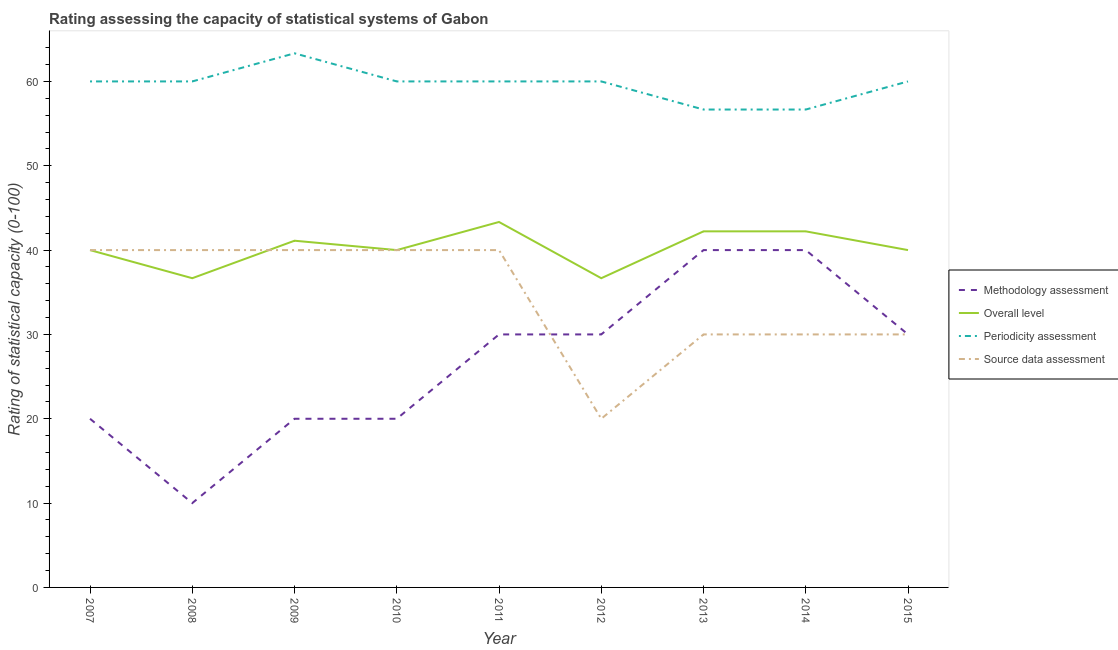Does the line corresponding to source data assessment rating intersect with the line corresponding to periodicity assessment rating?
Offer a very short reply. No. What is the source data assessment rating in 2015?
Make the answer very short. 30. Across all years, what is the maximum periodicity assessment rating?
Offer a terse response. 63.33. Across all years, what is the minimum source data assessment rating?
Your answer should be compact. 20. In which year was the methodology assessment rating maximum?
Make the answer very short. 2013. In which year was the methodology assessment rating minimum?
Your answer should be compact. 2008. What is the total source data assessment rating in the graph?
Your answer should be very brief. 310. What is the difference between the periodicity assessment rating in 2009 and that in 2013?
Ensure brevity in your answer.  6.67. What is the difference between the overall level rating in 2011 and the periodicity assessment rating in 2014?
Keep it short and to the point. -13.33. What is the average periodicity assessment rating per year?
Ensure brevity in your answer.  59.63. In the year 2013, what is the difference between the methodology assessment rating and overall level rating?
Offer a very short reply. -2.22. What is the ratio of the periodicity assessment rating in 2007 to that in 2013?
Provide a succinct answer. 1.06. Is the difference between the periodicity assessment rating in 2008 and 2015 greater than the difference between the methodology assessment rating in 2008 and 2015?
Provide a short and direct response. Yes. What is the difference between the highest and the lowest overall level rating?
Provide a succinct answer. 6.67. In how many years, is the source data assessment rating greater than the average source data assessment rating taken over all years?
Your response must be concise. 5. Does the overall level rating monotonically increase over the years?
Provide a short and direct response. No. Is the methodology assessment rating strictly less than the overall level rating over the years?
Keep it short and to the point. Yes. How many years are there in the graph?
Keep it short and to the point. 9. What is the difference between two consecutive major ticks on the Y-axis?
Ensure brevity in your answer.  10. Are the values on the major ticks of Y-axis written in scientific E-notation?
Make the answer very short. No. Where does the legend appear in the graph?
Provide a succinct answer. Center right. What is the title of the graph?
Keep it short and to the point. Rating assessing the capacity of statistical systems of Gabon. What is the label or title of the X-axis?
Ensure brevity in your answer.  Year. What is the label or title of the Y-axis?
Provide a short and direct response. Rating of statistical capacity (0-100). What is the Rating of statistical capacity (0-100) of Methodology assessment in 2007?
Your answer should be compact. 20. What is the Rating of statistical capacity (0-100) in Overall level in 2007?
Keep it short and to the point. 40. What is the Rating of statistical capacity (0-100) in Source data assessment in 2007?
Your answer should be very brief. 40. What is the Rating of statistical capacity (0-100) in Methodology assessment in 2008?
Make the answer very short. 10. What is the Rating of statistical capacity (0-100) of Overall level in 2008?
Your response must be concise. 36.67. What is the Rating of statistical capacity (0-100) of Periodicity assessment in 2008?
Provide a short and direct response. 60. What is the Rating of statistical capacity (0-100) in Methodology assessment in 2009?
Provide a short and direct response. 20. What is the Rating of statistical capacity (0-100) of Overall level in 2009?
Make the answer very short. 41.11. What is the Rating of statistical capacity (0-100) of Periodicity assessment in 2009?
Keep it short and to the point. 63.33. What is the Rating of statistical capacity (0-100) in Overall level in 2011?
Give a very brief answer. 43.33. What is the Rating of statistical capacity (0-100) in Periodicity assessment in 2011?
Provide a succinct answer. 60. What is the Rating of statistical capacity (0-100) in Source data assessment in 2011?
Keep it short and to the point. 40. What is the Rating of statistical capacity (0-100) of Overall level in 2012?
Ensure brevity in your answer.  36.67. What is the Rating of statistical capacity (0-100) in Periodicity assessment in 2012?
Offer a very short reply. 60. What is the Rating of statistical capacity (0-100) in Source data assessment in 2012?
Ensure brevity in your answer.  20. What is the Rating of statistical capacity (0-100) of Methodology assessment in 2013?
Give a very brief answer. 40. What is the Rating of statistical capacity (0-100) of Overall level in 2013?
Your response must be concise. 42.22. What is the Rating of statistical capacity (0-100) of Periodicity assessment in 2013?
Offer a terse response. 56.67. What is the Rating of statistical capacity (0-100) of Source data assessment in 2013?
Offer a very short reply. 30. What is the Rating of statistical capacity (0-100) of Overall level in 2014?
Your response must be concise. 42.22. What is the Rating of statistical capacity (0-100) of Periodicity assessment in 2014?
Keep it short and to the point. 56.67. What is the Rating of statistical capacity (0-100) in Source data assessment in 2014?
Your answer should be very brief. 30. What is the Rating of statistical capacity (0-100) of Overall level in 2015?
Provide a succinct answer. 40. What is the Rating of statistical capacity (0-100) of Periodicity assessment in 2015?
Make the answer very short. 60. What is the Rating of statistical capacity (0-100) of Source data assessment in 2015?
Provide a succinct answer. 30. Across all years, what is the maximum Rating of statistical capacity (0-100) of Overall level?
Offer a terse response. 43.33. Across all years, what is the maximum Rating of statistical capacity (0-100) in Periodicity assessment?
Your answer should be compact. 63.33. Across all years, what is the minimum Rating of statistical capacity (0-100) of Methodology assessment?
Make the answer very short. 10. Across all years, what is the minimum Rating of statistical capacity (0-100) in Overall level?
Ensure brevity in your answer.  36.67. Across all years, what is the minimum Rating of statistical capacity (0-100) of Periodicity assessment?
Provide a succinct answer. 56.67. What is the total Rating of statistical capacity (0-100) in Methodology assessment in the graph?
Your answer should be compact. 240. What is the total Rating of statistical capacity (0-100) in Overall level in the graph?
Provide a short and direct response. 362.22. What is the total Rating of statistical capacity (0-100) in Periodicity assessment in the graph?
Offer a terse response. 536.67. What is the total Rating of statistical capacity (0-100) of Source data assessment in the graph?
Offer a very short reply. 310. What is the difference between the Rating of statistical capacity (0-100) of Methodology assessment in 2007 and that in 2008?
Offer a very short reply. 10. What is the difference between the Rating of statistical capacity (0-100) in Source data assessment in 2007 and that in 2008?
Give a very brief answer. 0. What is the difference between the Rating of statistical capacity (0-100) of Methodology assessment in 2007 and that in 2009?
Provide a succinct answer. 0. What is the difference between the Rating of statistical capacity (0-100) of Overall level in 2007 and that in 2009?
Keep it short and to the point. -1.11. What is the difference between the Rating of statistical capacity (0-100) of Source data assessment in 2007 and that in 2009?
Offer a very short reply. 0. What is the difference between the Rating of statistical capacity (0-100) of Source data assessment in 2007 and that in 2010?
Provide a succinct answer. 0. What is the difference between the Rating of statistical capacity (0-100) of Periodicity assessment in 2007 and that in 2011?
Give a very brief answer. 0. What is the difference between the Rating of statistical capacity (0-100) of Source data assessment in 2007 and that in 2011?
Provide a succinct answer. 0. What is the difference between the Rating of statistical capacity (0-100) in Source data assessment in 2007 and that in 2012?
Ensure brevity in your answer.  20. What is the difference between the Rating of statistical capacity (0-100) in Methodology assessment in 2007 and that in 2013?
Offer a terse response. -20. What is the difference between the Rating of statistical capacity (0-100) of Overall level in 2007 and that in 2013?
Your answer should be compact. -2.22. What is the difference between the Rating of statistical capacity (0-100) in Methodology assessment in 2007 and that in 2014?
Provide a succinct answer. -20. What is the difference between the Rating of statistical capacity (0-100) in Overall level in 2007 and that in 2014?
Give a very brief answer. -2.22. What is the difference between the Rating of statistical capacity (0-100) of Periodicity assessment in 2007 and that in 2014?
Offer a terse response. 3.33. What is the difference between the Rating of statistical capacity (0-100) of Methodology assessment in 2007 and that in 2015?
Your answer should be compact. -10. What is the difference between the Rating of statistical capacity (0-100) in Periodicity assessment in 2007 and that in 2015?
Give a very brief answer. 0. What is the difference between the Rating of statistical capacity (0-100) in Source data assessment in 2007 and that in 2015?
Ensure brevity in your answer.  10. What is the difference between the Rating of statistical capacity (0-100) of Overall level in 2008 and that in 2009?
Offer a very short reply. -4.44. What is the difference between the Rating of statistical capacity (0-100) of Methodology assessment in 2008 and that in 2010?
Your answer should be compact. -10. What is the difference between the Rating of statistical capacity (0-100) of Source data assessment in 2008 and that in 2010?
Offer a very short reply. 0. What is the difference between the Rating of statistical capacity (0-100) of Methodology assessment in 2008 and that in 2011?
Keep it short and to the point. -20. What is the difference between the Rating of statistical capacity (0-100) of Overall level in 2008 and that in 2011?
Offer a very short reply. -6.67. What is the difference between the Rating of statistical capacity (0-100) in Overall level in 2008 and that in 2013?
Your response must be concise. -5.56. What is the difference between the Rating of statistical capacity (0-100) of Periodicity assessment in 2008 and that in 2013?
Your response must be concise. 3.33. What is the difference between the Rating of statistical capacity (0-100) in Source data assessment in 2008 and that in 2013?
Keep it short and to the point. 10. What is the difference between the Rating of statistical capacity (0-100) of Overall level in 2008 and that in 2014?
Give a very brief answer. -5.56. What is the difference between the Rating of statistical capacity (0-100) in Periodicity assessment in 2008 and that in 2014?
Give a very brief answer. 3.33. What is the difference between the Rating of statistical capacity (0-100) in Source data assessment in 2008 and that in 2014?
Make the answer very short. 10. What is the difference between the Rating of statistical capacity (0-100) in Overall level in 2008 and that in 2015?
Your answer should be compact. -3.33. What is the difference between the Rating of statistical capacity (0-100) in Periodicity assessment in 2008 and that in 2015?
Make the answer very short. 0. What is the difference between the Rating of statistical capacity (0-100) in Methodology assessment in 2009 and that in 2010?
Your response must be concise. 0. What is the difference between the Rating of statistical capacity (0-100) in Methodology assessment in 2009 and that in 2011?
Give a very brief answer. -10. What is the difference between the Rating of statistical capacity (0-100) of Overall level in 2009 and that in 2011?
Provide a short and direct response. -2.22. What is the difference between the Rating of statistical capacity (0-100) of Source data assessment in 2009 and that in 2011?
Your answer should be compact. 0. What is the difference between the Rating of statistical capacity (0-100) in Overall level in 2009 and that in 2012?
Keep it short and to the point. 4.44. What is the difference between the Rating of statistical capacity (0-100) of Source data assessment in 2009 and that in 2012?
Your answer should be very brief. 20. What is the difference between the Rating of statistical capacity (0-100) in Overall level in 2009 and that in 2013?
Give a very brief answer. -1.11. What is the difference between the Rating of statistical capacity (0-100) in Source data assessment in 2009 and that in 2013?
Make the answer very short. 10. What is the difference between the Rating of statistical capacity (0-100) in Methodology assessment in 2009 and that in 2014?
Your answer should be very brief. -20. What is the difference between the Rating of statistical capacity (0-100) of Overall level in 2009 and that in 2014?
Make the answer very short. -1.11. What is the difference between the Rating of statistical capacity (0-100) of Periodicity assessment in 2009 and that in 2014?
Make the answer very short. 6.67. What is the difference between the Rating of statistical capacity (0-100) in Source data assessment in 2009 and that in 2014?
Provide a succinct answer. 10. What is the difference between the Rating of statistical capacity (0-100) in Periodicity assessment in 2009 and that in 2015?
Offer a very short reply. 3.33. What is the difference between the Rating of statistical capacity (0-100) in Source data assessment in 2009 and that in 2015?
Your response must be concise. 10. What is the difference between the Rating of statistical capacity (0-100) in Methodology assessment in 2010 and that in 2011?
Provide a succinct answer. -10. What is the difference between the Rating of statistical capacity (0-100) of Periodicity assessment in 2010 and that in 2012?
Your response must be concise. 0. What is the difference between the Rating of statistical capacity (0-100) in Source data assessment in 2010 and that in 2012?
Provide a succinct answer. 20. What is the difference between the Rating of statistical capacity (0-100) of Methodology assessment in 2010 and that in 2013?
Your response must be concise. -20. What is the difference between the Rating of statistical capacity (0-100) of Overall level in 2010 and that in 2013?
Your answer should be very brief. -2.22. What is the difference between the Rating of statistical capacity (0-100) of Periodicity assessment in 2010 and that in 2013?
Keep it short and to the point. 3.33. What is the difference between the Rating of statistical capacity (0-100) in Overall level in 2010 and that in 2014?
Your answer should be compact. -2.22. What is the difference between the Rating of statistical capacity (0-100) of Methodology assessment in 2010 and that in 2015?
Make the answer very short. -10. What is the difference between the Rating of statistical capacity (0-100) in Overall level in 2010 and that in 2015?
Your answer should be compact. 0. What is the difference between the Rating of statistical capacity (0-100) in Periodicity assessment in 2010 and that in 2015?
Give a very brief answer. 0. What is the difference between the Rating of statistical capacity (0-100) of Source data assessment in 2010 and that in 2015?
Keep it short and to the point. 10. What is the difference between the Rating of statistical capacity (0-100) of Periodicity assessment in 2011 and that in 2012?
Keep it short and to the point. 0. What is the difference between the Rating of statistical capacity (0-100) in Source data assessment in 2011 and that in 2012?
Your answer should be very brief. 20. What is the difference between the Rating of statistical capacity (0-100) of Overall level in 2011 and that in 2013?
Your answer should be very brief. 1.11. What is the difference between the Rating of statistical capacity (0-100) of Periodicity assessment in 2011 and that in 2013?
Offer a terse response. 3.33. What is the difference between the Rating of statistical capacity (0-100) of Methodology assessment in 2011 and that in 2014?
Ensure brevity in your answer.  -10. What is the difference between the Rating of statistical capacity (0-100) of Periodicity assessment in 2011 and that in 2014?
Your response must be concise. 3.33. What is the difference between the Rating of statistical capacity (0-100) in Methodology assessment in 2011 and that in 2015?
Offer a very short reply. 0. What is the difference between the Rating of statistical capacity (0-100) of Overall level in 2011 and that in 2015?
Offer a very short reply. 3.33. What is the difference between the Rating of statistical capacity (0-100) of Periodicity assessment in 2011 and that in 2015?
Provide a short and direct response. 0. What is the difference between the Rating of statistical capacity (0-100) in Source data assessment in 2011 and that in 2015?
Ensure brevity in your answer.  10. What is the difference between the Rating of statistical capacity (0-100) in Methodology assessment in 2012 and that in 2013?
Your answer should be compact. -10. What is the difference between the Rating of statistical capacity (0-100) in Overall level in 2012 and that in 2013?
Offer a terse response. -5.56. What is the difference between the Rating of statistical capacity (0-100) in Periodicity assessment in 2012 and that in 2013?
Offer a terse response. 3.33. What is the difference between the Rating of statistical capacity (0-100) of Source data assessment in 2012 and that in 2013?
Make the answer very short. -10. What is the difference between the Rating of statistical capacity (0-100) of Overall level in 2012 and that in 2014?
Keep it short and to the point. -5.56. What is the difference between the Rating of statistical capacity (0-100) in Periodicity assessment in 2012 and that in 2014?
Keep it short and to the point. 3.33. What is the difference between the Rating of statistical capacity (0-100) in Methodology assessment in 2012 and that in 2015?
Provide a short and direct response. 0. What is the difference between the Rating of statistical capacity (0-100) of Periodicity assessment in 2012 and that in 2015?
Your answer should be very brief. 0. What is the difference between the Rating of statistical capacity (0-100) of Methodology assessment in 2013 and that in 2014?
Offer a very short reply. 0. What is the difference between the Rating of statistical capacity (0-100) of Overall level in 2013 and that in 2014?
Give a very brief answer. 0. What is the difference between the Rating of statistical capacity (0-100) of Periodicity assessment in 2013 and that in 2014?
Give a very brief answer. 0. What is the difference between the Rating of statistical capacity (0-100) of Overall level in 2013 and that in 2015?
Keep it short and to the point. 2.22. What is the difference between the Rating of statistical capacity (0-100) in Periodicity assessment in 2013 and that in 2015?
Provide a short and direct response. -3.33. What is the difference between the Rating of statistical capacity (0-100) in Overall level in 2014 and that in 2015?
Give a very brief answer. 2.22. What is the difference between the Rating of statistical capacity (0-100) of Periodicity assessment in 2014 and that in 2015?
Make the answer very short. -3.33. What is the difference between the Rating of statistical capacity (0-100) in Methodology assessment in 2007 and the Rating of statistical capacity (0-100) in Overall level in 2008?
Your answer should be very brief. -16.67. What is the difference between the Rating of statistical capacity (0-100) of Methodology assessment in 2007 and the Rating of statistical capacity (0-100) of Source data assessment in 2008?
Provide a short and direct response. -20. What is the difference between the Rating of statistical capacity (0-100) in Overall level in 2007 and the Rating of statistical capacity (0-100) in Periodicity assessment in 2008?
Offer a terse response. -20. What is the difference between the Rating of statistical capacity (0-100) in Overall level in 2007 and the Rating of statistical capacity (0-100) in Source data assessment in 2008?
Ensure brevity in your answer.  0. What is the difference between the Rating of statistical capacity (0-100) in Periodicity assessment in 2007 and the Rating of statistical capacity (0-100) in Source data assessment in 2008?
Your answer should be compact. 20. What is the difference between the Rating of statistical capacity (0-100) of Methodology assessment in 2007 and the Rating of statistical capacity (0-100) of Overall level in 2009?
Make the answer very short. -21.11. What is the difference between the Rating of statistical capacity (0-100) of Methodology assessment in 2007 and the Rating of statistical capacity (0-100) of Periodicity assessment in 2009?
Make the answer very short. -43.33. What is the difference between the Rating of statistical capacity (0-100) of Overall level in 2007 and the Rating of statistical capacity (0-100) of Periodicity assessment in 2009?
Give a very brief answer. -23.33. What is the difference between the Rating of statistical capacity (0-100) of Methodology assessment in 2007 and the Rating of statistical capacity (0-100) of Overall level in 2010?
Your answer should be very brief. -20. What is the difference between the Rating of statistical capacity (0-100) of Methodology assessment in 2007 and the Rating of statistical capacity (0-100) of Source data assessment in 2010?
Your answer should be very brief. -20. What is the difference between the Rating of statistical capacity (0-100) of Overall level in 2007 and the Rating of statistical capacity (0-100) of Periodicity assessment in 2010?
Your response must be concise. -20. What is the difference between the Rating of statistical capacity (0-100) in Methodology assessment in 2007 and the Rating of statistical capacity (0-100) in Overall level in 2011?
Give a very brief answer. -23.33. What is the difference between the Rating of statistical capacity (0-100) of Periodicity assessment in 2007 and the Rating of statistical capacity (0-100) of Source data assessment in 2011?
Make the answer very short. 20. What is the difference between the Rating of statistical capacity (0-100) of Methodology assessment in 2007 and the Rating of statistical capacity (0-100) of Overall level in 2012?
Your response must be concise. -16.67. What is the difference between the Rating of statistical capacity (0-100) of Methodology assessment in 2007 and the Rating of statistical capacity (0-100) of Periodicity assessment in 2012?
Your answer should be compact. -40. What is the difference between the Rating of statistical capacity (0-100) of Overall level in 2007 and the Rating of statistical capacity (0-100) of Periodicity assessment in 2012?
Keep it short and to the point. -20. What is the difference between the Rating of statistical capacity (0-100) of Periodicity assessment in 2007 and the Rating of statistical capacity (0-100) of Source data assessment in 2012?
Give a very brief answer. 40. What is the difference between the Rating of statistical capacity (0-100) of Methodology assessment in 2007 and the Rating of statistical capacity (0-100) of Overall level in 2013?
Offer a very short reply. -22.22. What is the difference between the Rating of statistical capacity (0-100) of Methodology assessment in 2007 and the Rating of statistical capacity (0-100) of Periodicity assessment in 2013?
Provide a short and direct response. -36.67. What is the difference between the Rating of statistical capacity (0-100) in Overall level in 2007 and the Rating of statistical capacity (0-100) in Periodicity assessment in 2013?
Your answer should be compact. -16.67. What is the difference between the Rating of statistical capacity (0-100) of Methodology assessment in 2007 and the Rating of statistical capacity (0-100) of Overall level in 2014?
Ensure brevity in your answer.  -22.22. What is the difference between the Rating of statistical capacity (0-100) in Methodology assessment in 2007 and the Rating of statistical capacity (0-100) in Periodicity assessment in 2014?
Provide a short and direct response. -36.67. What is the difference between the Rating of statistical capacity (0-100) in Overall level in 2007 and the Rating of statistical capacity (0-100) in Periodicity assessment in 2014?
Keep it short and to the point. -16.67. What is the difference between the Rating of statistical capacity (0-100) in Overall level in 2007 and the Rating of statistical capacity (0-100) in Source data assessment in 2014?
Provide a short and direct response. 10. What is the difference between the Rating of statistical capacity (0-100) of Periodicity assessment in 2007 and the Rating of statistical capacity (0-100) of Source data assessment in 2014?
Keep it short and to the point. 30. What is the difference between the Rating of statistical capacity (0-100) in Methodology assessment in 2007 and the Rating of statistical capacity (0-100) in Overall level in 2015?
Your response must be concise. -20. What is the difference between the Rating of statistical capacity (0-100) in Methodology assessment in 2007 and the Rating of statistical capacity (0-100) in Periodicity assessment in 2015?
Give a very brief answer. -40. What is the difference between the Rating of statistical capacity (0-100) of Methodology assessment in 2007 and the Rating of statistical capacity (0-100) of Source data assessment in 2015?
Offer a terse response. -10. What is the difference between the Rating of statistical capacity (0-100) in Overall level in 2007 and the Rating of statistical capacity (0-100) in Periodicity assessment in 2015?
Make the answer very short. -20. What is the difference between the Rating of statistical capacity (0-100) of Overall level in 2007 and the Rating of statistical capacity (0-100) of Source data assessment in 2015?
Make the answer very short. 10. What is the difference between the Rating of statistical capacity (0-100) of Periodicity assessment in 2007 and the Rating of statistical capacity (0-100) of Source data assessment in 2015?
Ensure brevity in your answer.  30. What is the difference between the Rating of statistical capacity (0-100) in Methodology assessment in 2008 and the Rating of statistical capacity (0-100) in Overall level in 2009?
Give a very brief answer. -31.11. What is the difference between the Rating of statistical capacity (0-100) of Methodology assessment in 2008 and the Rating of statistical capacity (0-100) of Periodicity assessment in 2009?
Provide a short and direct response. -53.33. What is the difference between the Rating of statistical capacity (0-100) in Overall level in 2008 and the Rating of statistical capacity (0-100) in Periodicity assessment in 2009?
Make the answer very short. -26.67. What is the difference between the Rating of statistical capacity (0-100) in Methodology assessment in 2008 and the Rating of statistical capacity (0-100) in Periodicity assessment in 2010?
Your answer should be compact. -50. What is the difference between the Rating of statistical capacity (0-100) of Methodology assessment in 2008 and the Rating of statistical capacity (0-100) of Source data assessment in 2010?
Provide a succinct answer. -30. What is the difference between the Rating of statistical capacity (0-100) in Overall level in 2008 and the Rating of statistical capacity (0-100) in Periodicity assessment in 2010?
Your response must be concise. -23.33. What is the difference between the Rating of statistical capacity (0-100) in Methodology assessment in 2008 and the Rating of statistical capacity (0-100) in Overall level in 2011?
Ensure brevity in your answer.  -33.33. What is the difference between the Rating of statistical capacity (0-100) in Methodology assessment in 2008 and the Rating of statistical capacity (0-100) in Periodicity assessment in 2011?
Offer a very short reply. -50. What is the difference between the Rating of statistical capacity (0-100) of Methodology assessment in 2008 and the Rating of statistical capacity (0-100) of Source data assessment in 2011?
Your response must be concise. -30. What is the difference between the Rating of statistical capacity (0-100) in Overall level in 2008 and the Rating of statistical capacity (0-100) in Periodicity assessment in 2011?
Your answer should be compact. -23.33. What is the difference between the Rating of statistical capacity (0-100) of Methodology assessment in 2008 and the Rating of statistical capacity (0-100) of Overall level in 2012?
Offer a terse response. -26.67. What is the difference between the Rating of statistical capacity (0-100) of Methodology assessment in 2008 and the Rating of statistical capacity (0-100) of Periodicity assessment in 2012?
Ensure brevity in your answer.  -50. What is the difference between the Rating of statistical capacity (0-100) of Methodology assessment in 2008 and the Rating of statistical capacity (0-100) of Source data assessment in 2012?
Offer a terse response. -10. What is the difference between the Rating of statistical capacity (0-100) in Overall level in 2008 and the Rating of statistical capacity (0-100) in Periodicity assessment in 2012?
Make the answer very short. -23.33. What is the difference between the Rating of statistical capacity (0-100) of Overall level in 2008 and the Rating of statistical capacity (0-100) of Source data assessment in 2012?
Your answer should be very brief. 16.67. What is the difference between the Rating of statistical capacity (0-100) of Methodology assessment in 2008 and the Rating of statistical capacity (0-100) of Overall level in 2013?
Your answer should be very brief. -32.22. What is the difference between the Rating of statistical capacity (0-100) in Methodology assessment in 2008 and the Rating of statistical capacity (0-100) in Periodicity assessment in 2013?
Make the answer very short. -46.67. What is the difference between the Rating of statistical capacity (0-100) of Overall level in 2008 and the Rating of statistical capacity (0-100) of Periodicity assessment in 2013?
Provide a succinct answer. -20. What is the difference between the Rating of statistical capacity (0-100) in Periodicity assessment in 2008 and the Rating of statistical capacity (0-100) in Source data assessment in 2013?
Your answer should be very brief. 30. What is the difference between the Rating of statistical capacity (0-100) of Methodology assessment in 2008 and the Rating of statistical capacity (0-100) of Overall level in 2014?
Offer a very short reply. -32.22. What is the difference between the Rating of statistical capacity (0-100) of Methodology assessment in 2008 and the Rating of statistical capacity (0-100) of Periodicity assessment in 2014?
Ensure brevity in your answer.  -46.67. What is the difference between the Rating of statistical capacity (0-100) in Methodology assessment in 2008 and the Rating of statistical capacity (0-100) in Periodicity assessment in 2015?
Give a very brief answer. -50. What is the difference between the Rating of statistical capacity (0-100) in Methodology assessment in 2008 and the Rating of statistical capacity (0-100) in Source data assessment in 2015?
Ensure brevity in your answer.  -20. What is the difference between the Rating of statistical capacity (0-100) of Overall level in 2008 and the Rating of statistical capacity (0-100) of Periodicity assessment in 2015?
Give a very brief answer. -23.33. What is the difference between the Rating of statistical capacity (0-100) of Methodology assessment in 2009 and the Rating of statistical capacity (0-100) of Overall level in 2010?
Your response must be concise. -20. What is the difference between the Rating of statistical capacity (0-100) in Methodology assessment in 2009 and the Rating of statistical capacity (0-100) in Source data assessment in 2010?
Give a very brief answer. -20. What is the difference between the Rating of statistical capacity (0-100) of Overall level in 2009 and the Rating of statistical capacity (0-100) of Periodicity assessment in 2010?
Your response must be concise. -18.89. What is the difference between the Rating of statistical capacity (0-100) of Overall level in 2009 and the Rating of statistical capacity (0-100) of Source data assessment in 2010?
Provide a short and direct response. 1.11. What is the difference between the Rating of statistical capacity (0-100) of Periodicity assessment in 2009 and the Rating of statistical capacity (0-100) of Source data assessment in 2010?
Offer a very short reply. 23.33. What is the difference between the Rating of statistical capacity (0-100) in Methodology assessment in 2009 and the Rating of statistical capacity (0-100) in Overall level in 2011?
Provide a short and direct response. -23.33. What is the difference between the Rating of statistical capacity (0-100) in Methodology assessment in 2009 and the Rating of statistical capacity (0-100) in Periodicity assessment in 2011?
Offer a terse response. -40. What is the difference between the Rating of statistical capacity (0-100) of Overall level in 2009 and the Rating of statistical capacity (0-100) of Periodicity assessment in 2011?
Your answer should be compact. -18.89. What is the difference between the Rating of statistical capacity (0-100) of Overall level in 2009 and the Rating of statistical capacity (0-100) of Source data assessment in 2011?
Your answer should be compact. 1.11. What is the difference between the Rating of statistical capacity (0-100) in Periodicity assessment in 2009 and the Rating of statistical capacity (0-100) in Source data assessment in 2011?
Keep it short and to the point. 23.33. What is the difference between the Rating of statistical capacity (0-100) in Methodology assessment in 2009 and the Rating of statistical capacity (0-100) in Overall level in 2012?
Keep it short and to the point. -16.67. What is the difference between the Rating of statistical capacity (0-100) of Methodology assessment in 2009 and the Rating of statistical capacity (0-100) of Source data assessment in 2012?
Ensure brevity in your answer.  0. What is the difference between the Rating of statistical capacity (0-100) in Overall level in 2009 and the Rating of statistical capacity (0-100) in Periodicity assessment in 2012?
Offer a terse response. -18.89. What is the difference between the Rating of statistical capacity (0-100) of Overall level in 2009 and the Rating of statistical capacity (0-100) of Source data assessment in 2012?
Your response must be concise. 21.11. What is the difference between the Rating of statistical capacity (0-100) of Periodicity assessment in 2009 and the Rating of statistical capacity (0-100) of Source data assessment in 2012?
Make the answer very short. 43.33. What is the difference between the Rating of statistical capacity (0-100) of Methodology assessment in 2009 and the Rating of statistical capacity (0-100) of Overall level in 2013?
Ensure brevity in your answer.  -22.22. What is the difference between the Rating of statistical capacity (0-100) of Methodology assessment in 2009 and the Rating of statistical capacity (0-100) of Periodicity assessment in 2013?
Provide a short and direct response. -36.67. What is the difference between the Rating of statistical capacity (0-100) of Overall level in 2009 and the Rating of statistical capacity (0-100) of Periodicity assessment in 2013?
Give a very brief answer. -15.56. What is the difference between the Rating of statistical capacity (0-100) of Overall level in 2009 and the Rating of statistical capacity (0-100) of Source data assessment in 2013?
Your answer should be compact. 11.11. What is the difference between the Rating of statistical capacity (0-100) of Periodicity assessment in 2009 and the Rating of statistical capacity (0-100) of Source data assessment in 2013?
Ensure brevity in your answer.  33.33. What is the difference between the Rating of statistical capacity (0-100) in Methodology assessment in 2009 and the Rating of statistical capacity (0-100) in Overall level in 2014?
Ensure brevity in your answer.  -22.22. What is the difference between the Rating of statistical capacity (0-100) of Methodology assessment in 2009 and the Rating of statistical capacity (0-100) of Periodicity assessment in 2014?
Offer a very short reply. -36.67. What is the difference between the Rating of statistical capacity (0-100) of Overall level in 2009 and the Rating of statistical capacity (0-100) of Periodicity assessment in 2014?
Ensure brevity in your answer.  -15.56. What is the difference between the Rating of statistical capacity (0-100) in Overall level in 2009 and the Rating of statistical capacity (0-100) in Source data assessment in 2014?
Your answer should be very brief. 11.11. What is the difference between the Rating of statistical capacity (0-100) in Periodicity assessment in 2009 and the Rating of statistical capacity (0-100) in Source data assessment in 2014?
Ensure brevity in your answer.  33.33. What is the difference between the Rating of statistical capacity (0-100) of Methodology assessment in 2009 and the Rating of statistical capacity (0-100) of Overall level in 2015?
Ensure brevity in your answer.  -20. What is the difference between the Rating of statistical capacity (0-100) of Methodology assessment in 2009 and the Rating of statistical capacity (0-100) of Periodicity assessment in 2015?
Keep it short and to the point. -40. What is the difference between the Rating of statistical capacity (0-100) of Overall level in 2009 and the Rating of statistical capacity (0-100) of Periodicity assessment in 2015?
Keep it short and to the point. -18.89. What is the difference between the Rating of statistical capacity (0-100) in Overall level in 2009 and the Rating of statistical capacity (0-100) in Source data assessment in 2015?
Make the answer very short. 11.11. What is the difference between the Rating of statistical capacity (0-100) in Periodicity assessment in 2009 and the Rating of statistical capacity (0-100) in Source data assessment in 2015?
Make the answer very short. 33.33. What is the difference between the Rating of statistical capacity (0-100) in Methodology assessment in 2010 and the Rating of statistical capacity (0-100) in Overall level in 2011?
Your answer should be very brief. -23.33. What is the difference between the Rating of statistical capacity (0-100) in Overall level in 2010 and the Rating of statistical capacity (0-100) in Source data assessment in 2011?
Make the answer very short. 0. What is the difference between the Rating of statistical capacity (0-100) in Methodology assessment in 2010 and the Rating of statistical capacity (0-100) in Overall level in 2012?
Provide a short and direct response. -16.67. What is the difference between the Rating of statistical capacity (0-100) in Methodology assessment in 2010 and the Rating of statistical capacity (0-100) in Source data assessment in 2012?
Your response must be concise. 0. What is the difference between the Rating of statistical capacity (0-100) of Periodicity assessment in 2010 and the Rating of statistical capacity (0-100) of Source data assessment in 2012?
Your answer should be compact. 40. What is the difference between the Rating of statistical capacity (0-100) of Methodology assessment in 2010 and the Rating of statistical capacity (0-100) of Overall level in 2013?
Offer a terse response. -22.22. What is the difference between the Rating of statistical capacity (0-100) in Methodology assessment in 2010 and the Rating of statistical capacity (0-100) in Periodicity assessment in 2013?
Your answer should be very brief. -36.67. What is the difference between the Rating of statistical capacity (0-100) in Overall level in 2010 and the Rating of statistical capacity (0-100) in Periodicity assessment in 2013?
Your response must be concise. -16.67. What is the difference between the Rating of statistical capacity (0-100) in Overall level in 2010 and the Rating of statistical capacity (0-100) in Source data assessment in 2013?
Make the answer very short. 10. What is the difference between the Rating of statistical capacity (0-100) in Methodology assessment in 2010 and the Rating of statistical capacity (0-100) in Overall level in 2014?
Provide a short and direct response. -22.22. What is the difference between the Rating of statistical capacity (0-100) in Methodology assessment in 2010 and the Rating of statistical capacity (0-100) in Periodicity assessment in 2014?
Provide a succinct answer. -36.67. What is the difference between the Rating of statistical capacity (0-100) in Overall level in 2010 and the Rating of statistical capacity (0-100) in Periodicity assessment in 2014?
Offer a terse response. -16.67. What is the difference between the Rating of statistical capacity (0-100) of Overall level in 2010 and the Rating of statistical capacity (0-100) of Source data assessment in 2014?
Your answer should be very brief. 10. What is the difference between the Rating of statistical capacity (0-100) of Methodology assessment in 2010 and the Rating of statistical capacity (0-100) of Periodicity assessment in 2015?
Give a very brief answer. -40. What is the difference between the Rating of statistical capacity (0-100) in Methodology assessment in 2010 and the Rating of statistical capacity (0-100) in Source data assessment in 2015?
Your answer should be compact. -10. What is the difference between the Rating of statistical capacity (0-100) in Overall level in 2010 and the Rating of statistical capacity (0-100) in Periodicity assessment in 2015?
Your response must be concise. -20. What is the difference between the Rating of statistical capacity (0-100) in Overall level in 2010 and the Rating of statistical capacity (0-100) in Source data assessment in 2015?
Offer a terse response. 10. What is the difference between the Rating of statistical capacity (0-100) in Periodicity assessment in 2010 and the Rating of statistical capacity (0-100) in Source data assessment in 2015?
Your answer should be compact. 30. What is the difference between the Rating of statistical capacity (0-100) in Methodology assessment in 2011 and the Rating of statistical capacity (0-100) in Overall level in 2012?
Provide a succinct answer. -6.67. What is the difference between the Rating of statistical capacity (0-100) of Methodology assessment in 2011 and the Rating of statistical capacity (0-100) of Periodicity assessment in 2012?
Your answer should be very brief. -30. What is the difference between the Rating of statistical capacity (0-100) in Overall level in 2011 and the Rating of statistical capacity (0-100) in Periodicity assessment in 2012?
Offer a very short reply. -16.67. What is the difference between the Rating of statistical capacity (0-100) of Overall level in 2011 and the Rating of statistical capacity (0-100) of Source data assessment in 2012?
Your response must be concise. 23.33. What is the difference between the Rating of statistical capacity (0-100) of Periodicity assessment in 2011 and the Rating of statistical capacity (0-100) of Source data assessment in 2012?
Offer a terse response. 40. What is the difference between the Rating of statistical capacity (0-100) in Methodology assessment in 2011 and the Rating of statistical capacity (0-100) in Overall level in 2013?
Ensure brevity in your answer.  -12.22. What is the difference between the Rating of statistical capacity (0-100) in Methodology assessment in 2011 and the Rating of statistical capacity (0-100) in Periodicity assessment in 2013?
Offer a very short reply. -26.67. What is the difference between the Rating of statistical capacity (0-100) in Overall level in 2011 and the Rating of statistical capacity (0-100) in Periodicity assessment in 2013?
Give a very brief answer. -13.33. What is the difference between the Rating of statistical capacity (0-100) in Overall level in 2011 and the Rating of statistical capacity (0-100) in Source data assessment in 2013?
Give a very brief answer. 13.33. What is the difference between the Rating of statistical capacity (0-100) of Methodology assessment in 2011 and the Rating of statistical capacity (0-100) of Overall level in 2014?
Give a very brief answer. -12.22. What is the difference between the Rating of statistical capacity (0-100) of Methodology assessment in 2011 and the Rating of statistical capacity (0-100) of Periodicity assessment in 2014?
Offer a very short reply. -26.67. What is the difference between the Rating of statistical capacity (0-100) of Methodology assessment in 2011 and the Rating of statistical capacity (0-100) of Source data assessment in 2014?
Offer a very short reply. 0. What is the difference between the Rating of statistical capacity (0-100) of Overall level in 2011 and the Rating of statistical capacity (0-100) of Periodicity assessment in 2014?
Give a very brief answer. -13.33. What is the difference between the Rating of statistical capacity (0-100) in Overall level in 2011 and the Rating of statistical capacity (0-100) in Source data assessment in 2014?
Provide a succinct answer. 13.33. What is the difference between the Rating of statistical capacity (0-100) in Periodicity assessment in 2011 and the Rating of statistical capacity (0-100) in Source data assessment in 2014?
Provide a succinct answer. 30. What is the difference between the Rating of statistical capacity (0-100) in Methodology assessment in 2011 and the Rating of statistical capacity (0-100) in Periodicity assessment in 2015?
Your response must be concise. -30. What is the difference between the Rating of statistical capacity (0-100) in Methodology assessment in 2011 and the Rating of statistical capacity (0-100) in Source data assessment in 2015?
Keep it short and to the point. 0. What is the difference between the Rating of statistical capacity (0-100) in Overall level in 2011 and the Rating of statistical capacity (0-100) in Periodicity assessment in 2015?
Offer a very short reply. -16.67. What is the difference between the Rating of statistical capacity (0-100) of Overall level in 2011 and the Rating of statistical capacity (0-100) of Source data assessment in 2015?
Offer a very short reply. 13.33. What is the difference between the Rating of statistical capacity (0-100) in Periodicity assessment in 2011 and the Rating of statistical capacity (0-100) in Source data assessment in 2015?
Your answer should be very brief. 30. What is the difference between the Rating of statistical capacity (0-100) in Methodology assessment in 2012 and the Rating of statistical capacity (0-100) in Overall level in 2013?
Offer a very short reply. -12.22. What is the difference between the Rating of statistical capacity (0-100) in Methodology assessment in 2012 and the Rating of statistical capacity (0-100) in Periodicity assessment in 2013?
Your answer should be very brief. -26.67. What is the difference between the Rating of statistical capacity (0-100) in Methodology assessment in 2012 and the Rating of statistical capacity (0-100) in Source data assessment in 2013?
Ensure brevity in your answer.  0. What is the difference between the Rating of statistical capacity (0-100) of Overall level in 2012 and the Rating of statistical capacity (0-100) of Periodicity assessment in 2013?
Provide a short and direct response. -20. What is the difference between the Rating of statistical capacity (0-100) in Periodicity assessment in 2012 and the Rating of statistical capacity (0-100) in Source data assessment in 2013?
Ensure brevity in your answer.  30. What is the difference between the Rating of statistical capacity (0-100) in Methodology assessment in 2012 and the Rating of statistical capacity (0-100) in Overall level in 2014?
Make the answer very short. -12.22. What is the difference between the Rating of statistical capacity (0-100) in Methodology assessment in 2012 and the Rating of statistical capacity (0-100) in Periodicity assessment in 2014?
Your answer should be very brief. -26.67. What is the difference between the Rating of statistical capacity (0-100) of Methodology assessment in 2012 and the Rating of statistical capacity (0-100) of Source data assessment in 2014?
Give a very brief answer. 0. What is the difference between the Rating of statistical capacity (0-100) in Overall level in 2012 and the Rating of statistical capacity (0-100) in Periodicity assessment in 2014?
Your response must be concise. -20. What is the difference between the Rating of statistical capacity (0-100) in Methodology assessment in 2012 and the Rating of statistical capacity (0-100) in Periodicity assessment in 2015?
Make the answer very short. -30. What is the difference between the Rating of statistical capacity (0-100) in Overall level in 2012 and the Rating of statistical capacity (0-100) in Periodicity assessment in 2015?
Offer a terse response. -23.33. What is the difference between the Rating of statistical capacity (0-100) in Methodology assessment in 2013 and the Rating of statistical capacity (0-100) in Overall level in 2014?
Your answer should be compact. -2.22. What is the difference between the Rating of statistical capacity (0-100) in Methodology assessment in 2013 and the Rating of statistical capacity (0-100) in Periodicity assessment in 2014?
Keep it short and to the point. -16.67. What is the difference between the Rating of statistical capacity (0-100) of Overall level in 2013 and the Rating of statistical capacity (0-100) of Periodicity assessment in 2014?
Your response must be concise. -14.44. What is the difference between the Rating of statistical capacity (0-100) of Overall level in 2013 and the Rating of statistical capacity (0-100) of Source data assessment in 2014?
Ensure brevity in your answer.  12.22. What is the difference between the Rating of statistical capacity (0-100) of Periodicity assessment in 2013 and the Rating of statistical capacity (0-100) of Source data assessment in 2014?
Offer a very short reply. 26.67. What is the difference between the Rating of statistical capacity (0-100) in Methodology assessment in 2013 and the Rating of statistical capacity (0-100) in Overall level in 2015?
Offer a terse response. 0. What is the difference between the Rating of statistical capacity (0-100) of Methodology assessment in 2013 and the Rating of statistical capacity (0-100) of Periodicity assessment in 2015?
Offer a terse response. -20. What is the difference between the Rating of statistical capacity (0-100) in Methodology assessment in 2013 and the Rating of statistical capacity (0-100) in Source data assessment in 2015?
Your response must be concise. 10. What is the difference between the Rating of statistical capacity (0-100) of Overall level in 2013 and the Rating of statistical capacity (0-100) of Periodicity assessment in 2015?
Provide a short and direct response. -17.78. What is the difference between the Rating of statistical capacity (0-100) of Overall level in 2013 and the Rating of statistical capacity (0-100) of Source data assessment in 2015?
Make the answer very short. 12.22. What is the difference between the Rating of statistical capacity (0-100) in Periodicity assessment in 2013 and the Rating of statistical capacity (0-100) in Source data assessment in 2015?
Keep it short and to the point. 26.67. What is the difference between the Rating of statistical capacity (0-100) in Methodology assessment in 2014 and the Rating of statistical capacity (0-100) in Periodicity assessment in 2015?
Keep it short and to the point. -20. What is the difference between the Rating of statistical capacity (0-100) in Overall level in 2014 and the Rating of statistical capacity (0-100) in Periodicity assessment in 2015?
Offer a terse response. -17.78. What is the difference between the Rating of statistical capacity (0-100) of Overall level in 2014 and the Rating of statistical capacity (0-100) of Source data assessment in 2015?
Offer a very short reply. 12.22. What is the difference between the Rating of statistical capacity (0-100) in Periodicity assessment in 2014 and the Rating of statistical capacity (0-100) in Source data assessment in 2015?
Provide a short and direct response. 26.67. What is the average Rating of statistical capacity (0-100) in Methodology assessment per year?
Make the answer very short. 26.67. What is the average Rating of statistical capacity (0-100) of Overall level per year?
Provide a succinct answer. 40.25. What is the average Rating of statistical capacity (0-100) of Periodicity assessment per year?
Give a very brief answer. 59.63. What is the average Rating of statistical capacity (0-100) of Source data assessment per year?
Offer a very short reply. 34.44. In the year 2007, what is the difference between the Rating of statistical capacity (0-100) in Methodology assessment and Rating of statistical capacity (0-100) in Overall level?
Offer a terse response. -20. In the year 2007, what is the difference between the Rating of statistical capacity (0-100) of Methodology assessment and Rating of statistical capacity (0-100) of Periodicity assessment?
Make the answer very short. -40. In the year 2007, what is the difference between the Rating of statistical capacity (0-100) of Methodology assessment and Rating of statistical capacity (0-100) of Source data assessment?
Make the answer very short. -20. In the year 2007, what is the difference between the Rating of statistical capacity (0-100) in Overall level and Rating of statistical capacity (0-100) in Periodicity assessment?
Offer a terse response. -20. In the year 2008, what is the difference between the Rating of statistical capacity (0-100) of Methodology assessment and Rating of statistical capacity (0-100) of Overall level?
Your answer should be very brief. -26.67. In the year 2008, what is the difference between the Rating of statistical capacity (0-100) in Methodology assessment and Rating of statistical capacity (0-100) in Periodicity assessment?
Offer a very short reply. -50. In the year 2008, what is the difference between the Rating of statistical capacity (0-100) in Overall level and Rating of statistical capacity (0-100) in Periodicity assessment?
Keep it short and to the point. -23.33. In the year 2008, what is the difference between the Rating of statistical capacity (0-100) in Periodicity assessment and Rating of statistical capacity (0-100) in Source data assessment?
Your answer should be very brief. 20. In the year 2009, what is the difference between the Rating of statistical capacity (0-100) of Methodology assessment and Rating of statistical capacity (0-100) of Overall level?
Your response must be concise. -21.11. In the year 2009, what is the difference between the Rating of statistical capacity (0-100) in Methodology assessment and Rating of statistical capacity (0-100) in Periodicity assessment?
Your answer should be very brief. -43.33. In the year 2009, what is the difference between the Rating of statistical capacity (0-100) of Methodology assessment and Rating of statistical capacity (0-100) of Source data assessment?
Offer a very short reply. -20. In the year 2009, what is the difference between the Rating of statistical capacity (0-100) in Overall level and Rating of statistical capacity (0-100) in Periodicity assessment?
Offer a terse response. -22.22. In the year 2009, what is the difference between the Rating of statistical capacity (0-100) in Periodicity assessment and Rating of statistical capacity (0-100) in Source data assessment?
Your answer should be compact. 23.33. In the year 2010, what is the difference between the Rating of statistical capacity (0-100) of Methodology assessment and Rating of statistical capacity (0-100) of Overall level?
Provide a succinct answer. -20. In the year 2010, what is the difference between the Rating of statistical capacity (0-100) in Methodology assessment and Rating of statistical capacity (0-100) in Source data assessment?
Give a very brief answer. -20. In the year 2010, what is the difference between the Rating of statistical capacity (0-100) of Overall level and Rating of statistical capacity (0-100) of Periodicity assessment?
Provide a short and direct response. -20. In the year 2010, what is the difference between the Rating of statistical capacity (0-100) of Periodicity assessment and Rating of statistical capacity (0-100) of Source data assessment?
Provide a succinct answer. 20. In the year 2011, what is the difference between the Rating of statistical capacity (0-100) in Methodology assessment and Rating of statistical capacity (0-100) in Overall level?
Keep it short and to the point. -13.33. In the year 2011, what is the difference between the Rating of statistical capacity (0-100) in Methodology assessment and Rating of statistical capacity (0-100) in Periodicity assessment?
Offer a very short reply. -30. In the year 2011, what is the difference between the Rating of statistical capacity (0-100) in Overall level and Rating of statistical capacity (0-100) in Periodicity assessment?
Keep it short and to the point. -16.67. In the year 2011, what is the difference between the Rating of statistical capacity (0-100) of Overall level and Rating of statistical capacity (0-100) of Source data assessment?
Offer a terse response. 3.33. In the year 2012, what is the difference between the Rating of statistical capacity (0-100) of Methodology assessment and Rating of statistical capacity (0-100) of Overall level?
Provide a short and direct response. -6.67. In the year 2012, what is the difference between the Rating of statistical capacity (0-100) in Methodology assessment and Rating of statistical capacity (0-100) in Periodicity assessment?
Ensure brevity in your answer.  -30. In the year 2012, what is the difference between the Rating of statistical capacity (0-100) in Methodology assessment and Rating of statistical capacity (0-100) in Source data assessment?
Offer a very short reply. 10. In the year 2012, what is the difference between the Rating of statistical capacity (0-100) of Overall level and Rating of statistical capacity (0-100) of Periodicity assessment?
Make the answer very short. -23.33. In the year 2012, what is the difference between the Rating of statistical capacity (0-100) of Overall level and Rating of statistical capacity (0-100) of Source data assessment?
Offer a very short reply. 16.67. In the year 2013, what is the difference between the Rating of statistical capacity (0-100) in Methodology assessment and Rating of statistical capacity (0-100) in Overall level?
Your answer should be very brief. -2.22. In the year 2013, what is the difference between the Rating of statistical capacity (0-100) of Methodology assessment and Rating of statistical capacity (0-100) of Periodicity assessment?
Your answer should be compact. -16.67. In the year 2013, what is the difference between the Rating of statistical capacity (0-100) in Overall level and Rating of statistical capacity (0-100) in Periodicity assessment?
Provide a short and direct response. -14.44. In the year 2013, what is the difference between the Rating of statistical capacity (0-100) in Overall level and Rating of statistical capacity (0-100) in Source data assessment?
Offer a terse response. 12.22. In the year 2013, what is the difference between the Rating of statistical capacity (0-100) in Periodicity assessment and Rating of statistical capacity (0-100) in Source data assessment?
Offer a terse response. 26.67. In the year 2014, what is the difference between the Rating of statistical capacity (0-100) of Methodology assessment and Rating of statistical capacity (0-100) of Overall level?
Your answer should be compact. -2.22. In the year 2014, what is the difference between the Rating of statistical capacity (0-100) of Methodology assessment and Rating of statistical capacity (0-100) of Periodicity assessment?
Offer a terse response. -16.67. In the year 2014, what is the difference between the Rating of statistical capacity (0-100) of Methodology assessment and Rating of statistical capacity (0-100) of Source data assessment?
Make the answer very short. 10. In the year 2014, what is the difference between the Rating of statistical capacity (0-100) in Overall level and Rating of statistical capacity (0-100) in Periodicity assessment?
Make the answer very short. -14.44. In the year 2014, what is the difference between the Rating of statistical capacity (0-100) of Overall level and Rating of statistical capacity (0-100) of Source data assessment?
Your answer should be compact. 12.22. In the year 2014, what is the difference between the Rating of statistical capacity (0-100) in Periodicity assessment and Rating of statistical capacity (0-100) in Source data assessment?
Give a very brief answer. 26.67. In the year 2015, what is the difference between the Rating of statistical capacity (0-100) in Methodology assessment and Rating of statistical capacity (0-100) in Overall level?
Offer a terse response. -10. In the year 2015, what is the difference between the Rating of statistical capacity (0-100) in Methodology assessment and Rating of statistical capacity (0-100) in Periodicity assessment?
Keep it short and to the point. -30. In the year 2015, what is the difference between the Rating of statistical capacity (0-100) in Overall level and Rating of statistical capacity (0-100) in Periodicity assessment?
Provide a succinct answer. -20. In the year 2015, what is the difference between the Rating of statistical capacity (0-100) of Periodicity assessment and Rating of statistical capacity (0-100) of Source data assessment?
Provide a succinct answer. 30. What is the ratio of the Rating of statistical capacity (0-100) of Overall level in 2007 to that in 2008?
Offer a very short reply. 1.09. What is the ratio of the Rating of statistical capacity (0-100) in Source data assessment in 2007 to that in 2008?
Offer a terse response. 1. What is the ratio of the Rating of statistical capacity (0-100) in Methodology assessment in 2007 to that in 2009?
Make the answer very short. 1. What is the ratio of the Rating of statistical capacity (0-100) of Overall level in 2007 to that in 2009?
Your response must be concise. 0.97. What is the ratio of the Rating of statistical capacity (0-100) in Periodicity assessment in 2007 to that in 2009?
Your response must be concise. 0.95. What is the ratio of the Rating of statistical capacity (0-100) in Methodology assessment in 2007 to that in 2010?
Offer a terse response. 1. What is the ratio of the Rating of statistical capacity (0-100) in Overall level in 2007 to that in 2010?
Make the answer very short. 1. What is the ratio of the Rating of statistical capacity (0-100) in Periodicity assessment in 2007 to that in 2010?
Give a very brief answer. 1. What is the ratio of the Rating of statistical capacity (0-100) in Methodology assessment in 2007 to that in 2011?
Offer a very short reply. 0.67. What is the ratio of the Rating of statistical capacity (0-100) in Overall level in 2007 to that in 2011?
Make the answer very short. 0.92. What is the ratio of the Rating of statistical capacity (0-100) of Methodology assessment in 2007 to that in 2012?
Your response must be concise. 0.67. What is the ratio of the Rating of statistical capacity (0-100) of Source data assessment in 2007 to that in 2012?
Provide a succinct answer. 2. What is the ratio of the Rating of statistical capacity (0-100) of Periodicity assessment in 2007 to that in 2013?
Your answer should be very brief. 1.06. What is the ratio of the Rating of statistical capacity (0-100) in Source data assessment in 2007 to that in 2013?
Offer a very short reply. 1.33. What is the ratio of the Rating of statistical capacity (0-100) of Methodology assessment in 2007 to that in 2014?
Offer a very short reply. 0.5. What is the ratio of the Rating of statistical capacity (0-100) of Periodicity assessment in 2007 to that in 2014?
Offer a very short reply. 1.06. What is the ratio of the Rating of statistical capacity (0-100) in Methodology assessment in 2007 to that in 2015?
Your response must be concise. 0.67. What is the ratio of the Rating of statistical capacity (0-100) of Periodicity assessment in 2007 to that in 2015?
Your answer should be very brief. 1. What is the ratio of the Rating of statistical capacity (0-100) in Source data assessment in 2007 to that in 2015?
Your response must be concise. 1.33. What is the ratio of the Rating of statistical capacity (0-100) in Overall level in 2008 to that in 2009?
Ensure brevity in your answer.  0.89. What is the ratio of the Rating of statistical capacity (0-100) of Periodicity assessment in 2008 to that in 2009?
Ensure brevity in your answer.  0.95. What is the ratio of the Rating of statistical capacity (0-100) of Source data assessment in 2008 to that in 2009?
Make the answer very short. 1. What is the ratio of the Rating of statistical capacity (0-100) in Methodology assessment in 2008 to that in 2010?
Your response must be concise. 0.5. What is the ratio of the Rating of statistical capacity (0-100) in Overall level in 2008 to that in 2010?
Your answer should be very brief. 0.92. What is the ratio of the Rating of statistical capacity (0-100) of Periodicity assessment in 2008 to that in 2010?
Your response must be concise. 1. What is the ratio of the Rating of statistical capacity (0-100) of Source data assessment in 2008 to that in 2010?
Give a very brief answer. 1. What is the ratio of the Rating of statistical capacity (0-100) in Methodology assessment in 2008 to that in 2011?
Offer a very short reply. 0.33. What is the ratio of the Rating of statistical capacity (0-100) in Overall level in 2008 to that in 2011?
Offer a very short reply. 0.85. What is the ratio of the Rating of statistical capacity (0-100) in Periodicity assessment in 2008 to that in 2011?
Keep it short and to the point. 1. What is the ratio of the Rating of statistical capacity (0-100) of Source data assessment in 2008 to that in 2011?
Keep it short and to the point. 1. What is the ratio of the Rating of statistical capacity (0-100) in Methodology assessment in 2008 to that in 2012?
Ensure brevity in your answer.  0.33. What is the ratio of the Rating of statistical capacity (0-100) in Source data assessment in 2008 to that in 2012?
Offer a terse response. 2. What is the ratio of the Rating of statistical capacity (0-100) of Methodology assessment in 2008 to that in 2013?
Offer a terse response. 0.25. What is the ratio of the Rating of statistical capacity (0-100) in Overall level in 2008 to that in 2013?
Make the answer very short. 0.87. What is the ratio of the Rating of statistical capacity (0-100) in Periodicity assessment in 2008 to that in 2013?
Ensure brevity in your answer.  1.06. What is the ratio of the Rating of statistical capacity (0-100) of Overall level in 2008 to that in 2014?
Give a very brief answer. 0.87. What is the ratio of the Rating of statistical capacity (0-100) of Periodicity assessment in 2008 to that in 2014?
Your response must be concise. 1.06. What is the ratio of the Rating of statistical capacity (0-100) of Source data assessment in 2008 to that in 2014?
Ensure brevity in your answer.  1.33. What is the ratio of the Rating of statistical capacity (0-100) of Overall level in 2008 to that in 2015?
Make the answer very short. 0.92. What is the ratio of the Rating of statistical capacity (0-100) in Periodicity assessment in 2008 to that in 2015?
Your answer should be very brief. 1. What is the ratio of the Rating of statistical capacity (0-100) in Source data assessment in 2008 to that in 2015?
Your answer should be compact. 1.33. What is the ratio of the Rating of statistical capacity (0-100) of Overall level in 2009 to that in 2010?
Keep it short and to the point. 1.03. What is the ratio of the Rating of statistical capacity (0-100) of Periodicity assessment in 2009 to that in 2010?
Your answer should be compact. 1.06. What is the ratio of the Rating of statistical capacity (0-100) of Methodology assessment in 2009 to that in 2011?
Provide a succinct answer. 0.67. What is the ratio of the Rating of statistical capacity (0-100) of Overall level in 2009 to that in 2011?
Your answer should be very brief. 0.95. What is the ratio of the Rating of statistical capacity (0-100) of Periodicity assessment in 2009 to that in 2011?
Your answer should be very brief. 1.06. What is the ratio of the Rating of statistical capacity (0-100) in Overall level in 2009 to that in 2012?
Your response must be concise. 1.12. What is the ratio of the Rating of statistical capacity (0-100) in Periodicity assessment in 2009 to that in 2012?
Ensure brevity in your answer.  1.06. What is the ratio of the Rating of statistical capacity (0-100) in Overall level in 2009 to that in 2013?
Make the answer very short. 0.97. What is the ratio of the Rating of statistical capacity (0-100) of Periodicity assessment in 2009 to that in 2013?
Keep it short and to the point. 1.12. What is the ratio of the Rating of statistical capacity (0-100) in Source data assessment in 2009 to that in 2013?
Give a very brief answer. 1.33. What is the ratio of the Rating of statistical capacity (0-100) of Methodology assessment in 2009 to that in 2014?
Your response must be concise. 0.5. What is the ratio of the Rating of statistical capacity (0-100) in Overall level in 2009 to that in 2014?
Ensure brevity in your answer.  0.97. What is the ratio of the Rating of statistical capacity (0-100) in Periodicity assessment in 2009 to that in 2014?
Your answer should be very brief. 1.12. What is the ratio of the Rating of statistical capacity (0-100) in Overall level in 2009 to that in 2015?
Offer a very short reply. 1.03. What is the ratio of the Rating of statistical capacity (0-100) of Periodicity assessment in 2009 to that in 2015?
Give a very brief answer. 1.06. What is the ratio of the Rating of statistical capacity (0-100) in Source data assessment in 2009 to that in 2015?
Your answer should be very brief. 1.33. What is the ratio of the Rating of statistical capacity (0-100) in Overall level in 2010 to that in 2011?
Provide a short and direct response. 0.92. What is the ratio of the Rating of statistical capacity (0-100) of Periodicity assessment in 2010 to that in 2011?
Your answer should be compact. 1. What is the ratio of the Rating of statistical capacity (0-100) in Source data assessment in 2010 to that in 2011?
Provide a short and direct response. 1. What is the ratio of the Rating of statistical capacity (0-100) in Overall level in 2010 to that in 2012?
Your answer should be very brief. 1.09. What is the ratio of the Rating of statistical capacity (0-100) in Source data assessment in 2010 to that in 2012?
Offer a very short reply. 2. What is the ratio of the Rating of statistical capacity (0-100) in Methodology assessment in 2010 to that in 2013?
Your response must be concise. 0.5. What is the ratio of the Rating of statistical capacity (0-100) of Periodicity assessment in 2010 to that in 2013?
Offer a very short reply. 1.06. What is the ratio of the Rating of statistical capacity (0-100) of Periodicity assessment in 2010 to that in 2014?
Provide a short and direct response. 1.06. What is the ratio of the Rating of statistical capacity (0-100) in Methodology assessment in 2010 to that in 2015?
Provide a succinct answer. 0.67. What is the ratio of the Rating of statistical capacity (0-100) of Periodicity assessment in 2010 to that in 2015?
Your answer should be compact. 1. What is the ratio of the Rating of statistical capacity (0-100) in Source data assessment in 2010 to that in 2015?
Offer a terse response. 1.33. What is the ratio of the Rating of statistical capacity (0-100) in Methodology assessment in 2011 to that in 2012?
Your answer should be very brief. 1. What is the ratio of the Rating of statistical capacity (0-100) in Overall level in 2011 to that in 2012?
Provide a short and direct response. 1.18. What is the ratio of the Rating of statistical capacity (0-100) of Periodicity assessment in 2011 to that in 2012?
Your response must be concise. 1. What is the ratio of the Rating of statistical capacity (0-100) in Methodology assessment in 2011 to that in 2013?
Keep it short and to the point. 0.75. What is the ratio of the Rating of statistical capacity (0-100) of Overall level in 2011 to that in 2013?
Give a very brief answer. 1.03. What is the ratio of the Rating of statistical capacity (0-100) of Periodicity assessment in 2011 to that in 2013?
Ensure brevity in your answer.  1.06. What is the ratio of the Rating of statistical capacity (0-100) in Source data assessment in 2011 to that in 2013?
Your answer should be compact. 1.33. What is the ratio of the Rating of statistical capacity (0-100) in Overall level in 2011 to that in 2014?
Provide a succinct answer. 1.03. What is the ratio of the Rating of statistical capacity (0-100) in Periodicity assessment in 2011 to that in 2014?
Offer a very short reply. 1.06. What is the ratio of the Rating of statistical capacity (0-100) of Source data assessment in 2011 to that in 2014?
Make the answer very short. 1.33. What is the ratio of the Rating of statistical capacity (0-100) in Methodology assessment in 2011 to that in 2015?
Provide a succinct answer. 1. What is the ratio of the Rating of statistical capacity (0-100) of Overall level in 2011 to that in 2015?
Your answer should be very brief. 1.08. What is the ratio of the Rating of statistical capacity (0-100) in Source data assessment in 2011 to that in 2015?
Offer a terse response. 1.33. What is the ratio of the Rating of statistical capacity (0-100) of Overall level in 2012 to that in 2013?
Provide a short and direct response. 0.87. What is the ratio of the Rating of statistical capacity (0-100) in Periodicity assessment in 2012 to that in 2013?
Offer a terse response. 1.06. What is the ratio of the Rating of statistical capacity (0-100) in Overall level in 2012 to that in 2014?
Give a very brief answer. 0.87. What is the ratio of the Rating of statistical capacity (0-100) of Periodicity assessment in 2012 to that in 2014?
Your answer should be very brief. 1.06. What is the ratio of the Rating of statistical capacity (0-100) in Source data assessment in 2012 to that in 2014?
Your response must be concise. 0.67. What is the ratio of the Rating of statistical capacity (0-100) of Source data assessment in 2012 to that in 2015?
Provide a succinct answer. 0.67. What is the ratio of the Rating of statistical capacity (0-100) of Methodology assessment in 2013 to that in 2014?
Provide a short and direct response. 1. What is the ratio of the Rating of statistical capacity (0-100) in Overall level in 2013 to that in 2014?
Your answer should be very brief. 1. What is the ratio of the Rating of statistical capacity (0-100) of Periodicity assessment in 2013 to that in 2014?
Give a very brief answer. 1. What is the ratio of the Rating of statistical capacity (0-100) of Methodology assessment in 2013 to that in 2015?
Offer a terse response. 1.33. What is the ratio of the Rating of statistical capacity (0-100) in Overall level in 2013 to that in 2015?
Your answer should be very brief. 1.06. What is the ratio of the Rating of statistical capacity (0-100) in Periodicity assessment in 2013 to that in 2015?
Your answer should be very brief. 0.94. What is the ratio of the Rating of statistical capacity (0-100) in Source data assessment in 2013 to that in 2015?
Provide a short and direct response. 1. What is the ratio of the Rating of statistical capacity (0-100) in Methodology assessment in 2014 to that in 2015?
Make the answer very short. 1.33. What is the ratio of the Rating of statistical capacity (0-100) of Overall level in 2014 to that in 2015?
Provide a short and direct response. 1.06. What is the ratio of the Rating of statistical capacity (0-100) of Periodicity assessment in 2014 to that in 2015?
Offer a terse response. 0.94. What is the difference between the highest and the second highest Rating of statistical capacity (0-100) of Periodicity assessment?
Provide a short and direct response. 3.33. What is the difference between the highest and the second highest Rating of statistical capacity (0-100) of Source data assessment?
Offer a very short reply. 0. What is the difference between the highest and the lowest Rating of statistical capacity (0-100) in Methodology assessment?
Ensure brevity in your answer.  30. What is the difference between the highest and the lowest Rating of statistical capacity (0-100) in Overall level?
Offer a very short reply. 6.67. What is the difference between the highest and the lowest Rating of statistical capacity (0-100) in Source data assessment?
Provide a short and direct response. 20. 